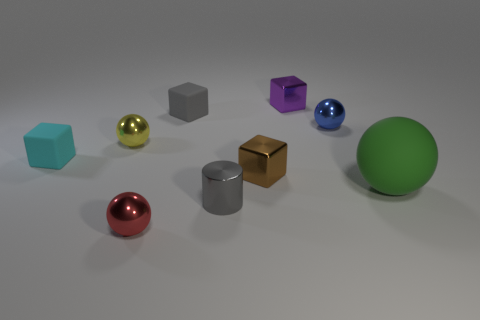Subtract all purple cubes. How many cubes are left? 3 Subtract all large rubber balls. How many balls are left? 3 Subtract all gray spheres. Subtract all yellow cubes. How many spheres are left? 4 Add 1 gray cubes. How many objects exist? 10 Subtract all cylinders. How many objects are left? 8 Subtract 0 cyan balls. How many objects are left? 9 Subtract all big red matte blocks. Subtract all tiny red objects. How many objects are left? 8 Add 8 gray shiny objects. How many gray shiny objects are left? 9 Add 9 large green rubber objects. How many large green rubber objects exist? 10 